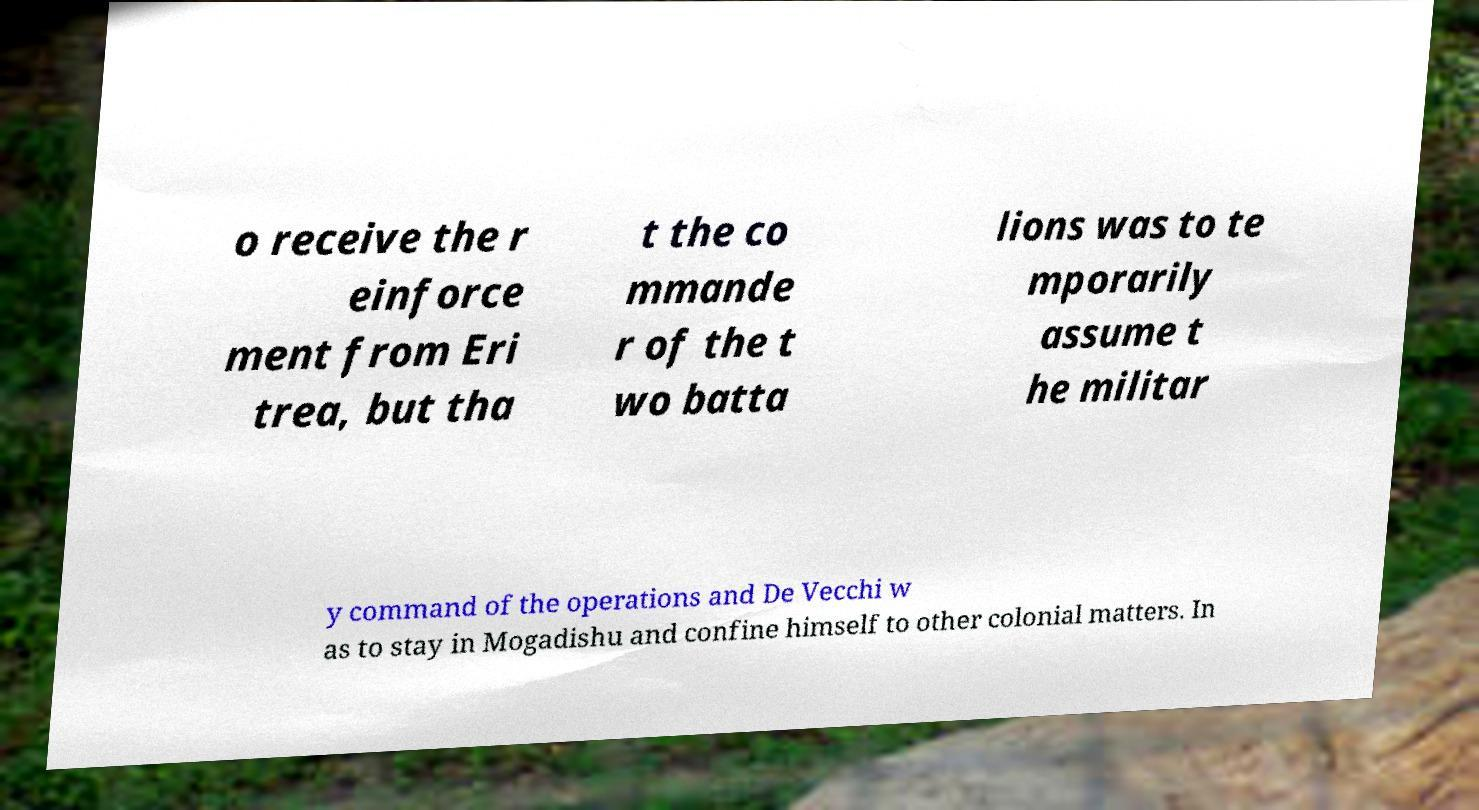For documentation purposes, I need the text within this image transcribed. Could you provide that? o receive the r einforce ment from Eri trea, but tha t the co mmande r of the t wo batta lions was to te mporarily assume t he militar y command of the operations and De Vecchi w as to stay in Mogadishu and confine himself to other colonial matters. In 